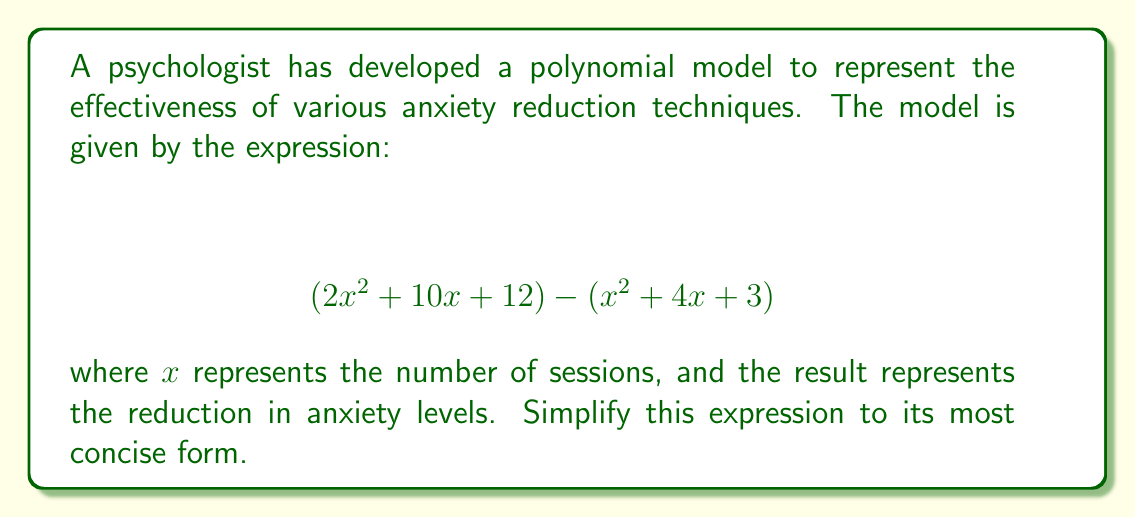Give your solution to this math problem. To simplify this polynomial expression, we'll follow these steps:

1) First, let's identify the terms in each part of the expression:
   $$(2x^2 + 10x + 12) - (x^2 + 4x + 3)$$

2) The subtraction operation means we need to subtract each term of the second polynomial from the corresponding term of the first polynomial:

   $2x^2 - x^2 = x^2$
   $10x - 4x = 6x$
   $12 - 3 = 9$

3) Now we can write our simplified polynomial:

   $$x^2 + 6x + 9$$

4) This polynomial can be further factored. It's a perfect square trinomial:

   $$x^2 + 6x + 9 = (x + 3)^2$$

5) Therefore, the most simplified form of the original expression is $(x + 3)^2$.

This simplified form represents a quadratic model for anxiety reduction, suggesting that the effectiveness of the techniques increases exponentially with the number of sessions, reaching its peak when $x = -3$ (which isn't practically applicable in this context, as the number of sessions can't be negative).
Answer: $(x + 3)^2$ 